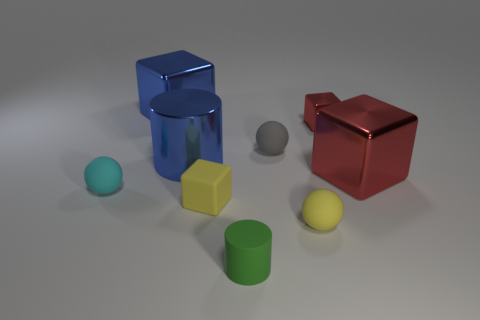What shape is the tiny object that is both in front of the small matte block and right of the rubber cylinder?
Offer a very short reply. Sphere. There is another thing that is the same color as the tiny metallic thing; what size is it?
Give a very brief answer. Large. There is a small sphere in front of the cyan ball that is to the left of the large cylinder; what is its material?
Provide a short and direct response. Rubber. Are there any small yellow balls on the right side of the big blue cylinder?
Provide a short and direct response. Yes. Are there more red metallic cubes left of the small green object than big red things?
Ensure brevity in your answer.  No. Is there another small shiny cylinder that has the same color as the metal cylinder?
Give a very brief answer. No. What is the color of the rubber cube that is the same size as the gray sphere?
Make the answer very short. Yellow. Are there any big shiny cylinders right of the rubber sphere in front of the cyan ball?
Give a very brief answer. No. What is the ball left of the matte cube made of?
Offer a very short reply. Rubber. Are the big block left of the tiny matte cube and the big cube that is on the right side of the small yellow ball made of the same material?
Keep it short and to the point. Yes. 